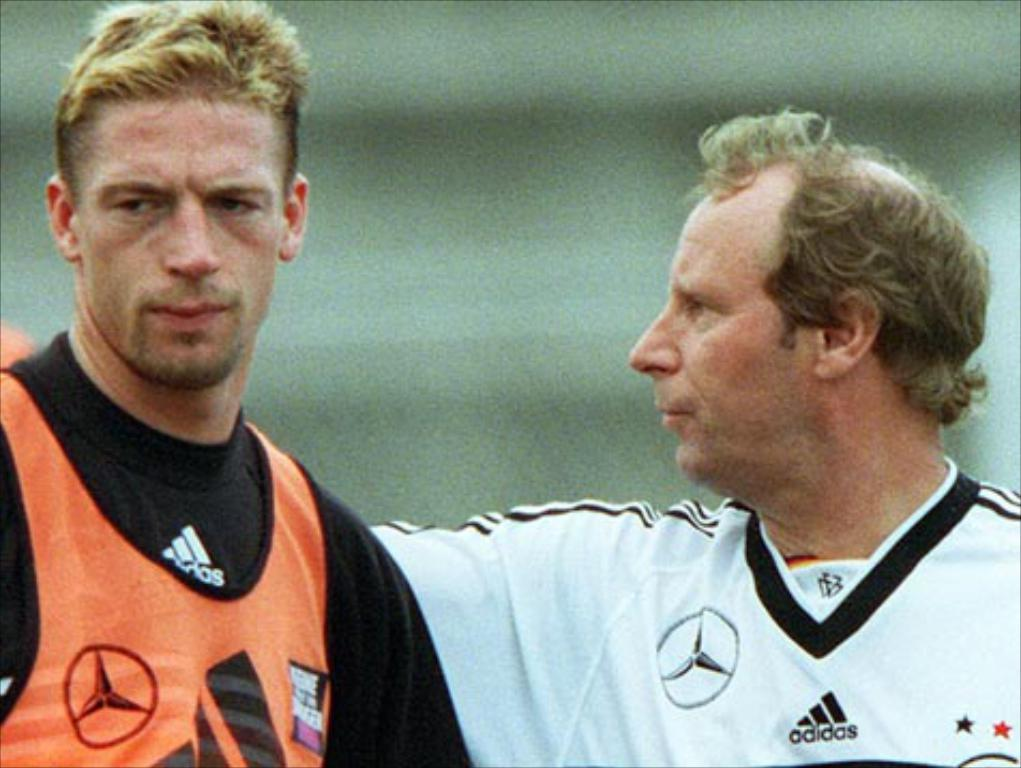<image>
Present a compact description of the photo's key features. two men with adidas jerseys with unhappy looks on their faces 